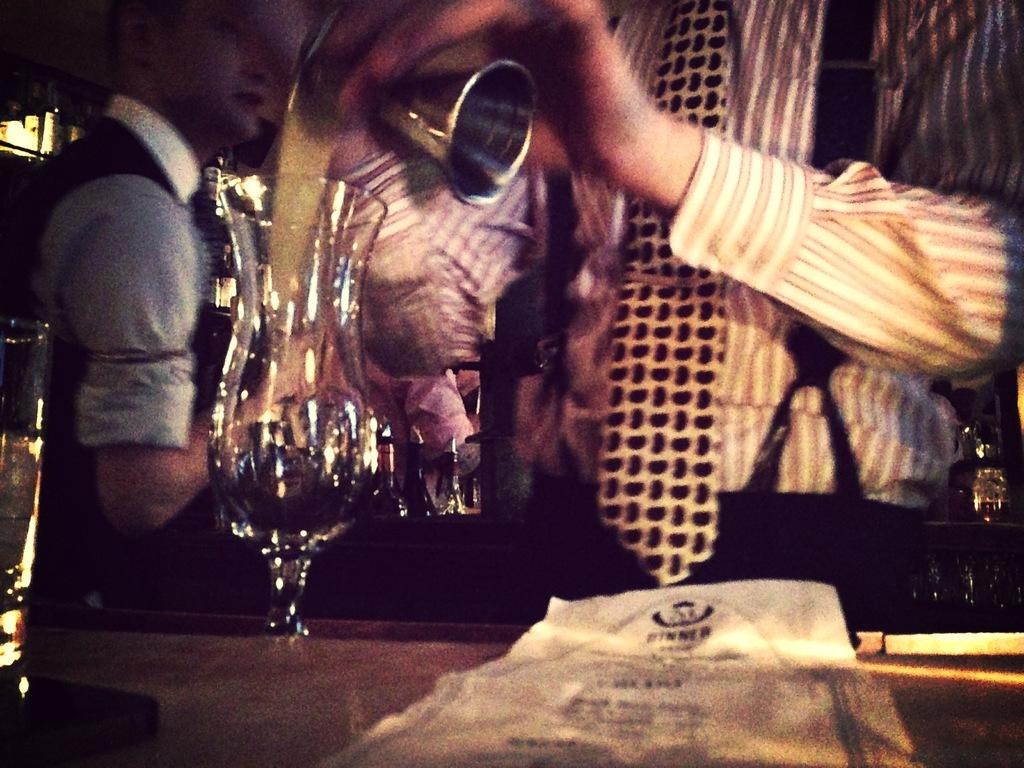Who is the main subject in the image? There is a man in the image. Where is the man located in relation to the image? The man is towards the right. What is the man doing in the image? The man is pouring liquid into a glass. Where is the glass located in the image? The glass is on a table. Are there any other people in the image? Yes, there is another man in the image. Where is the second man located in relation to the image? The second man is towards the left. What type of balls can be seen rolling on the table in the image? There are no balls present in the image; the man is pouring liquid into a glass. What is the crack in the image used for? There is no crack present in the image. 